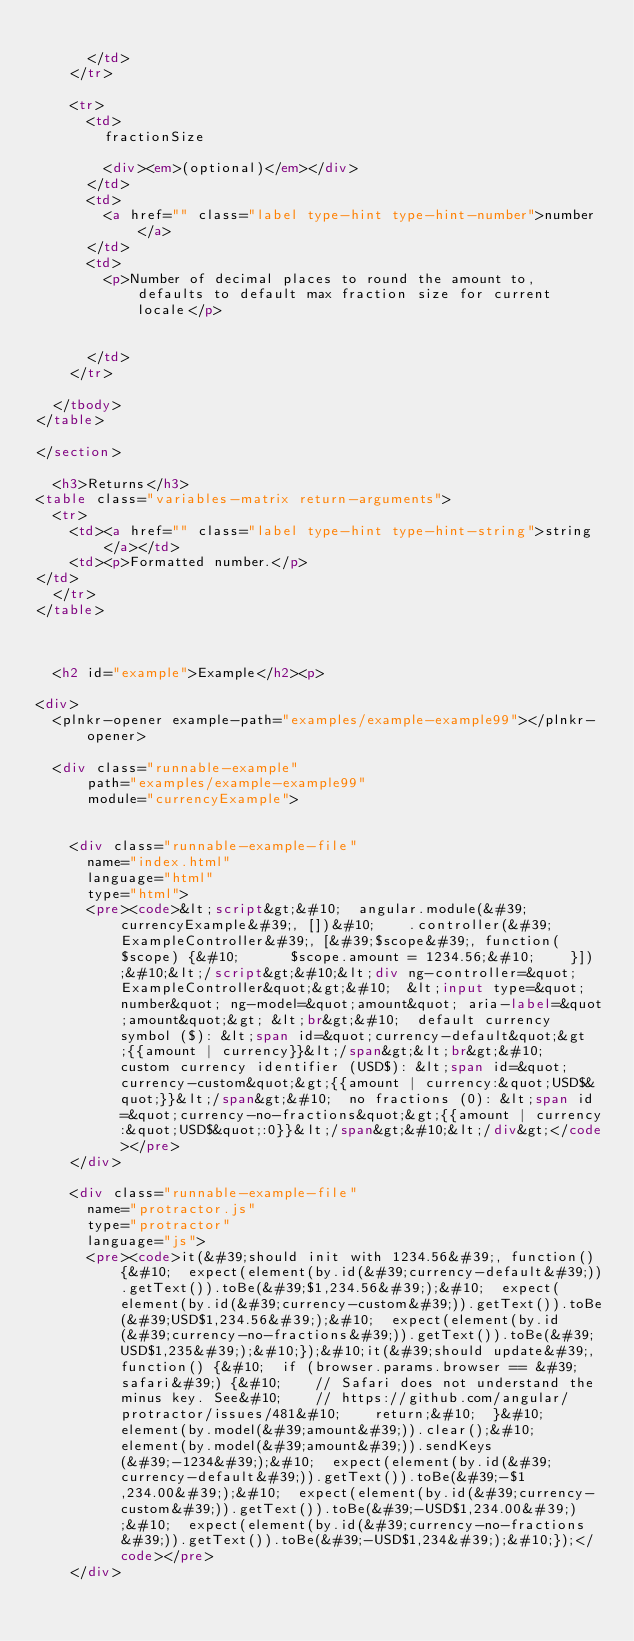Convert code to text. <code><loc_0><loc_0><loc_500><loc_500><_HTML_>        
      </td>
    </tr>
    
    <tr>
      <td>
        fractionSize
        
        <div><em>(optional)</em></div>
      </td>
      <td>
        <a href="" class="label type-hint type-hint-number">number</a>
      </td>
      <td>
        <p>Number of decimal places to round the amount to, defaults to default max fraction size for current locale</p>

        
      </td>
    </tr>
    
  </tbody>
</table>

</section>
  
  <h3>Returns</h3>
<table class="variables-matrix return-arguments">
  <tr>
    <td><a href="" class="label type-hint type-hint-string">string</a></td>
    <td><p>Formatted number.</p>
</td>
  </tr>
</table>


  
  <h2 id="example">Example</h2><p>

<div>
  <plnkr-opener example-path="examples/example-example99"></plnkr-opener>

  <div class="runnable-example"
      path="examples/example-example99"
      module="currencyExample">

  
    <div class="runnable-example-file" 
      name="index.html"
      language="html"
      type="html">
      <pre><code>&lt;script&gt;&#10;  angular.module(&#39;currencyExample&#39;, [])&#10;    .controller(&#39;ExampleController&#39;, [&#39;$scope&#39;, function($scope) {&#10;      $scope.amount = 1234.56;&#10;    }]);&#10;&lt;/script&gt;&#10;&lt;div ng-controller=&quot;ExampleController&quot;&gt;&#10;  &lt;input type=&quot;number&quot; ng-model=&quot;amount&quot; aria-label=&quot;amount&quot;&gt; &lt;br&gt;&#10;  default currency symbol ($): &lt;span id=&quot;currency-default&quot;&gt;{{amount | currency}}&lt;/span&gt;&lt;br&gt;&#10;  custom currency identifier (USD$): &lt;span id=&quot;currency-custom&quot;&gt;{{amount | currency:&quot;USD$&quot;}}&lt;/span&gt;&#10;  no fractions (0): &lt;span id=&quot;currency-no-fractions&quot;&gt;{{amount | currency:&quot;USD$&quot;:0}}&lt;/span&gt;&#10;&lt;/div&gt;</code></pre>
    </div>
  
    <div class="runnable-example-file" 
      name="protractor.js"
      type="protractor"
      language="js">
      <pre><code>it(&#39;should init with 1234.56&#39;, function() {&#10;  expect(element(by.id(&#39;currency-default&#39;)).getText()).toBe(&#39;$1,234.56&#39;);&#10;  expect(element(by.id(&#39;currency-custom&#39;)).getText()).toBe(&#39;USD$1,234.56&#39;);&#10;  expect(element(by.id(&#39;currency-no-fractions&#39;)).getText()).toBe(&#39;USD$1,235&#39;);&#10;});&#10;it(&#39;should update&#39;, function() {&#10;  if (browser.params.browser == &#39;safari&#39;) {&#10;    // Safari does not understand the minus key. See&#10;    // https://github.com/angular/protractor/issues/481&#10;    return;&#10;  }&#10;  element(by.model(&#39;amount&#39;)).clear();&#10;  element(by.model(&#39;amount&#39;)).sendKeys(&#39;-1234&#39;);&#10;  expect(element(by.id(&#39;currency-default&#39;)).getText()).toBe(&#39;-$1,234.00&#39;);&#10;  expect(element(by.id(&#39;currency-custom&#39;)).getText()).toBe(&#39;-USD$1,234.00&#39;);&#10;  expect(element(by.id(&#39;currency-no-fractions&#39;)).getText()).toBe(&#39;-USD$1,234&#39;);&#10;});</code></pre>
    </div>
  
</code> 